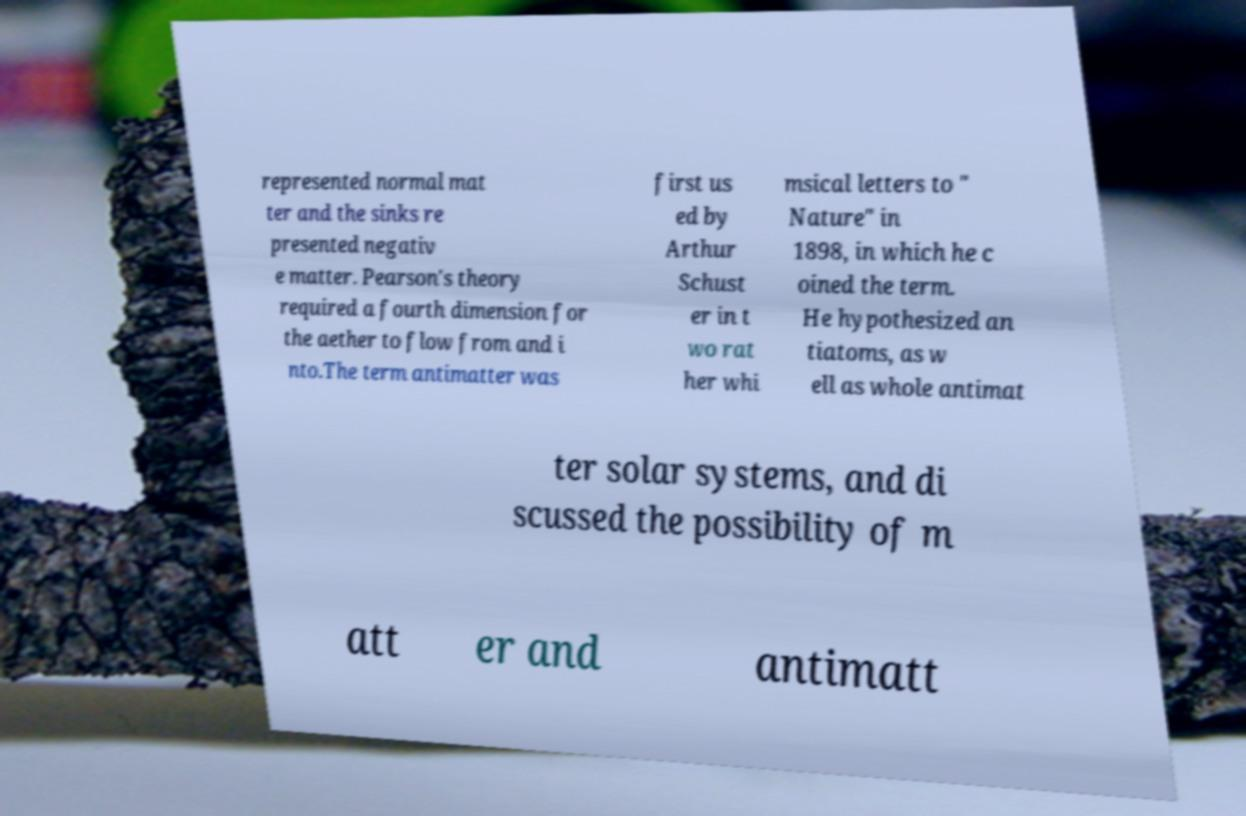What messages or text are displayed in this image? I need them in a readable, typed format. represented normal mat ter and the sinks re presented negativ e matter. Pearson's theory required a fourth dimension for the aether to flow from and i nto.The term antimatter was first us ed by Arthur Schust er in t wo rat her whi msical letters to " Nature" in 1898, in which he c oined the term. He hypothesized an tiatoms, as w ell as whole antimat ter solar systems, and di scussed the possibility of m att er and antimatt 